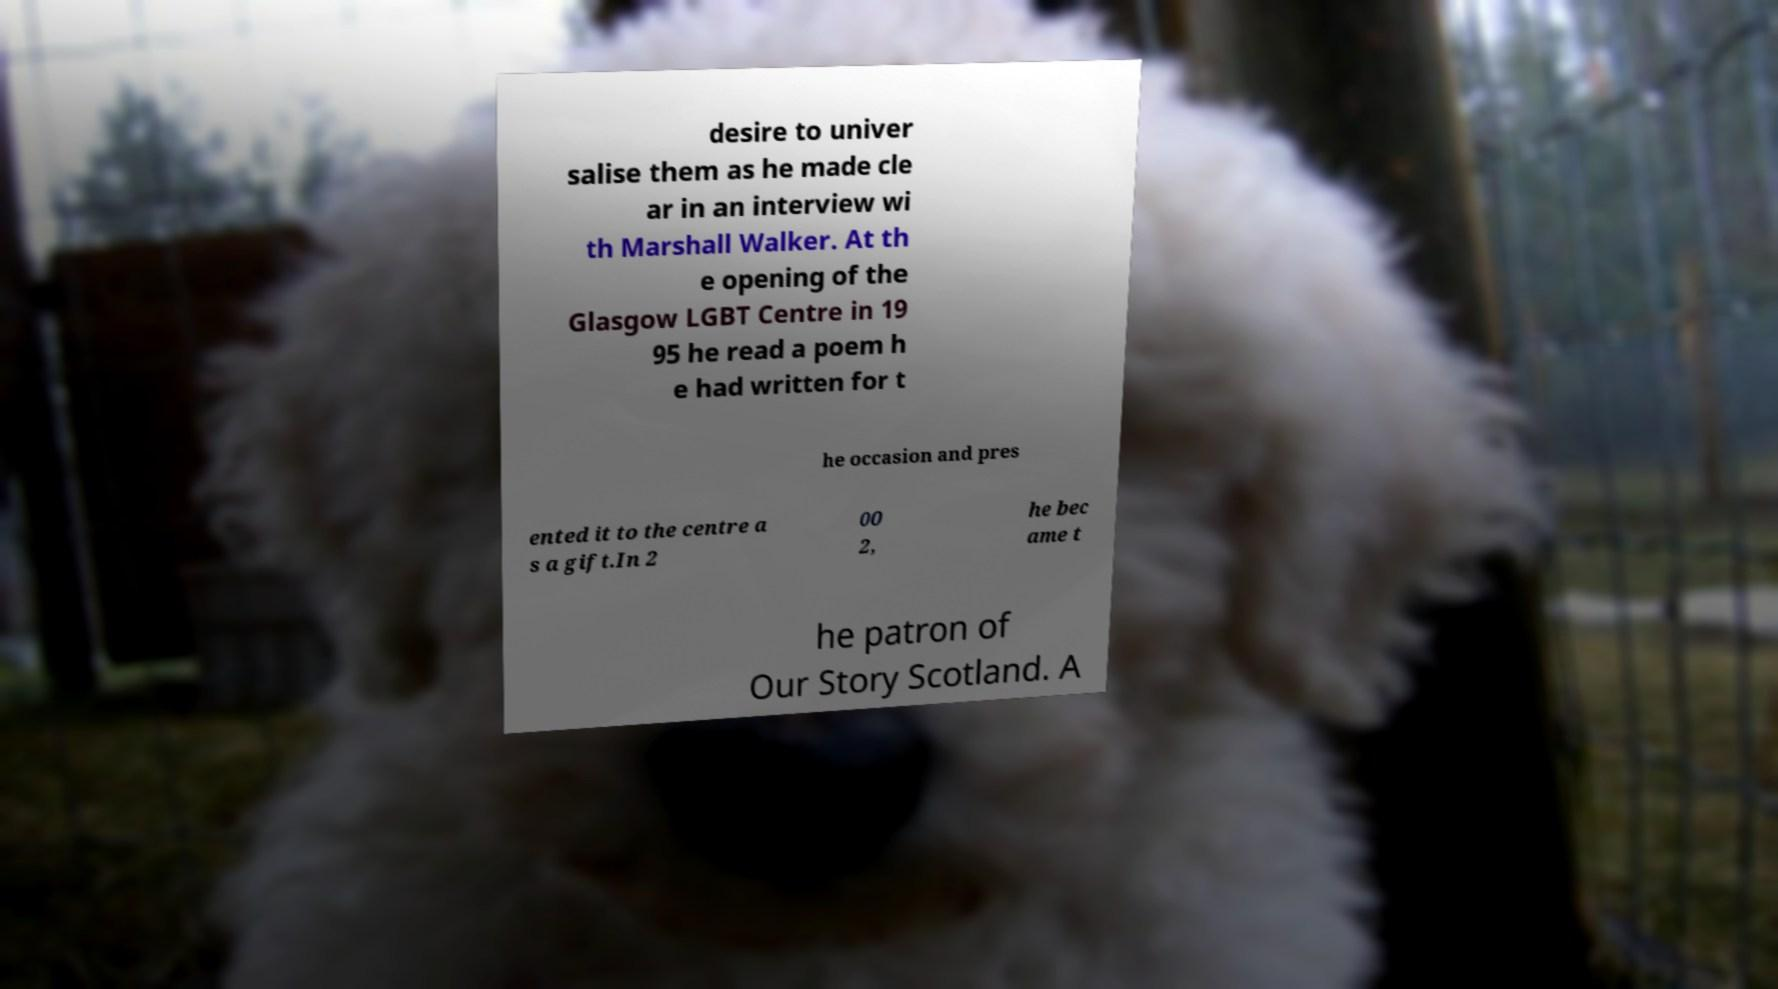Could you assist in decoding the text presented in this image and type it out clearly? desire to univer salise them as he made cle ar in an interview wi th Marshall Walker. At th e opening of the Glasgow LGBT Centre in 19 95 he read a poem h e had written for t he occasion and pres ented it to the centre a s a gift.In 2 00 2, he bec ame t he patron of Our Story Scotland. A 